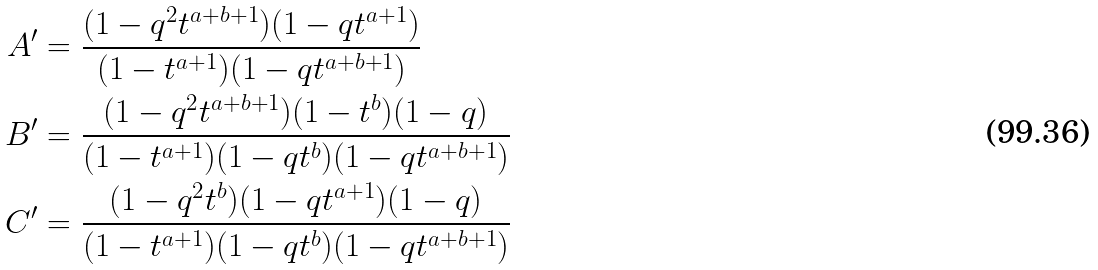Convert formula to latex. <formula><loc_0><loc_0><loc_500><loc_500>A ^ { \prime } & = \frac { ( 1 - q ^ { 2 } t ^ { a + b + 1 } ) ( 1 - q t ^ { a + 1 } ) } { ( 1 - t ^ { a + 1 } ) ( 1 - q t ^ { a + b + 1 } ) } \\ B ^ { \prime } & = \frac { ( 1 - q ^ { 2 } t ^ { a + b + 1 } ) ( 1 - t ^ { b } ) ( 1 - q ) } { ( 1 - t ^ { a + 1 } ) ( 1 - q t ^ { b } ) ( 1 - q t ^ { a + b + 1 } ) } \\ C ^ { \prime } & = \frac { ( 1 - q ^ { 2 } t ^ { b } ) ( 1 - q t ^ { a + 1 } ) ( 1 - q ) } { ( 1 - t ^ { a + 1 } ) ( 1 - q t ^ { b } ) ( 1 - q t ^ { a + b + 1 } ) }</formula> 